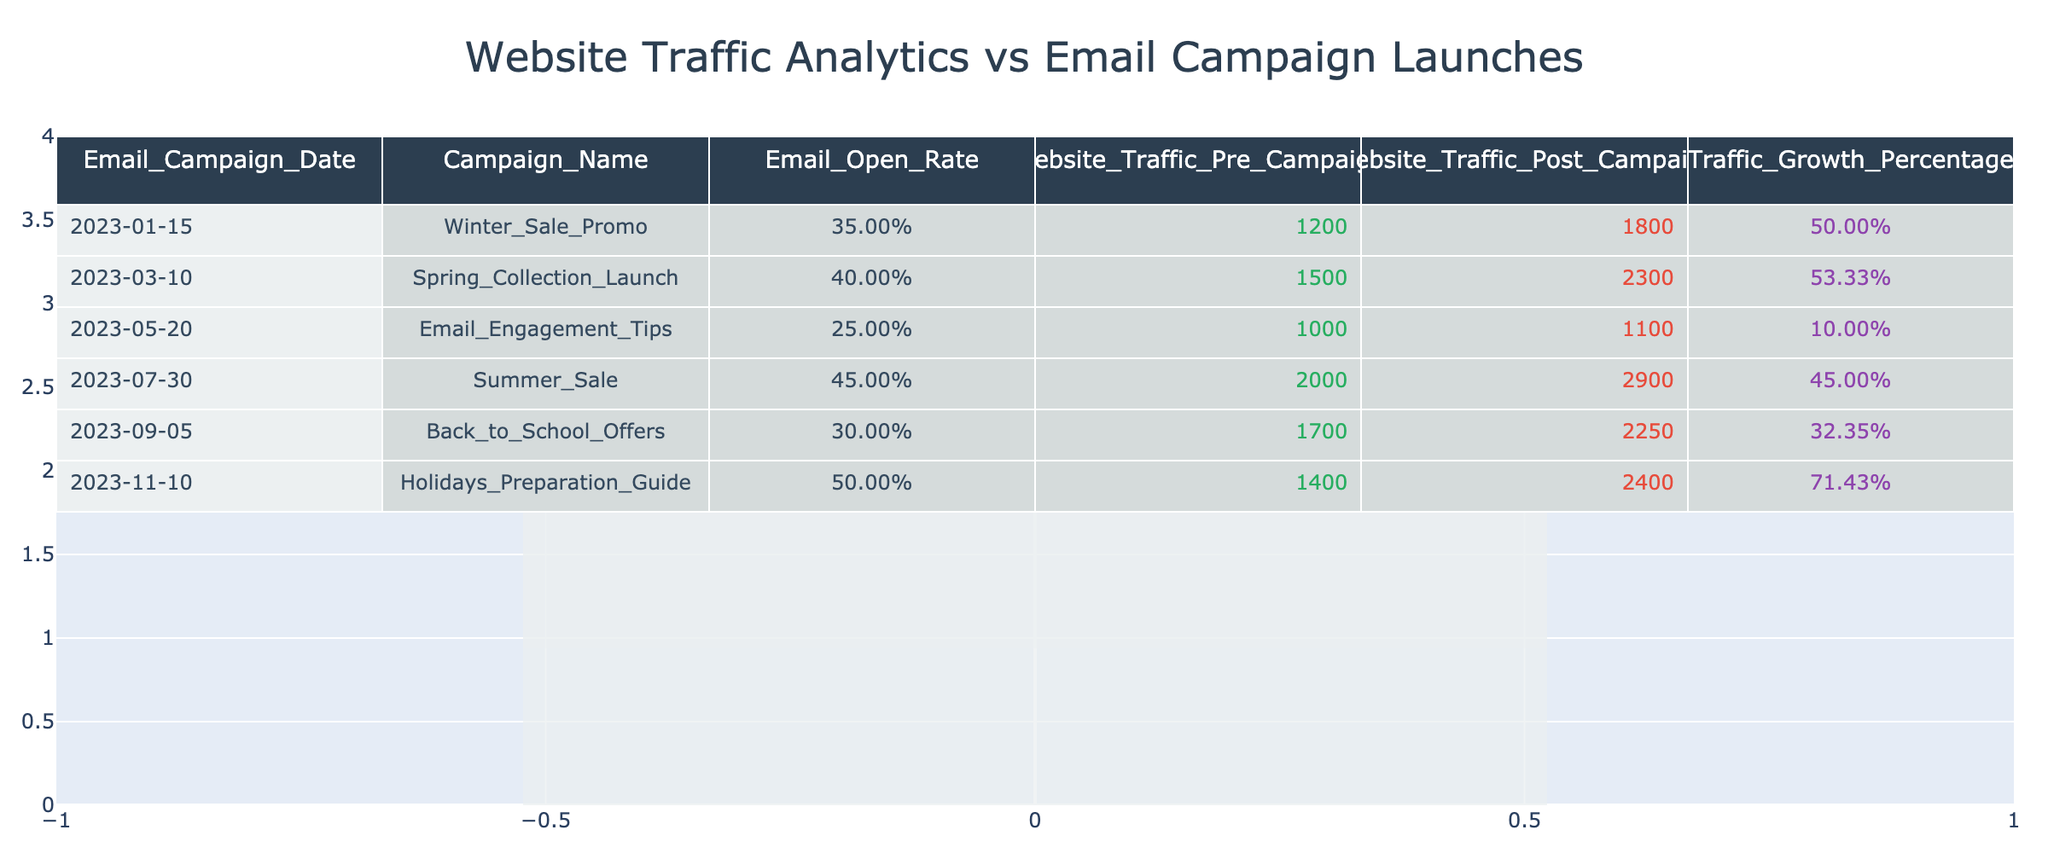What was the email open rate for the Summer Sale campaign? The table shows the email open rates for each campaign. For the Summer Sale campaign, which occurred on July 30, the email open rate is listed as 45%.
Answer: 45% Which campaign resulted in the highest traffic growth percentage? By examining the Traffic Growth Percentage column, the Holidays Preparation Guide campaign on November 10 shows the highest traffic growth at 71.43%.
Answer: 71.43% Did the Spring Collection Launch campaign increase website traffic by more than 50%? The Website Traffic Post Campaign for the Spring Collection Launch is 2300, and the Website Traffic Pre Campaign is 1500. The growth percentage is calculated as ((2300 - 1500) / 1500) * 100 = 53.33%, which is greater than 50%.
Answer: Yes What is the average email open rate across all campaigns? The email open rates for all campaigns are 35%, 40%, 25%, 45%, 30%, and 50%. To find the average, we sum these rates: 35 + 40 + 25 + 45 + 30 + 50 = 225. Since there are 6 campaigns, the average is 225 / 6 = 37.5%.
Answer: 37.5% How many campaigns had a traffic growth percentage above 40%? We will check the Traffic Growth Percentage column. The campaigns with traffic growth percentages above 40% are: Winter Sale Promo (50%), Spring Collection Launch (53.33%), Summer Sale (45%), and Holidays Preparation Guide (71.43%). Thus, there are 4 such campaigns.
Answer: 4 Which email campaign had the lowest traffic post campaign figure? Reviewing the Website Traffic Post Campaign column, the Email Engagement Tips campaign on May 20 had the lowest post campaign traffic at 1100.
Answer: 1100 